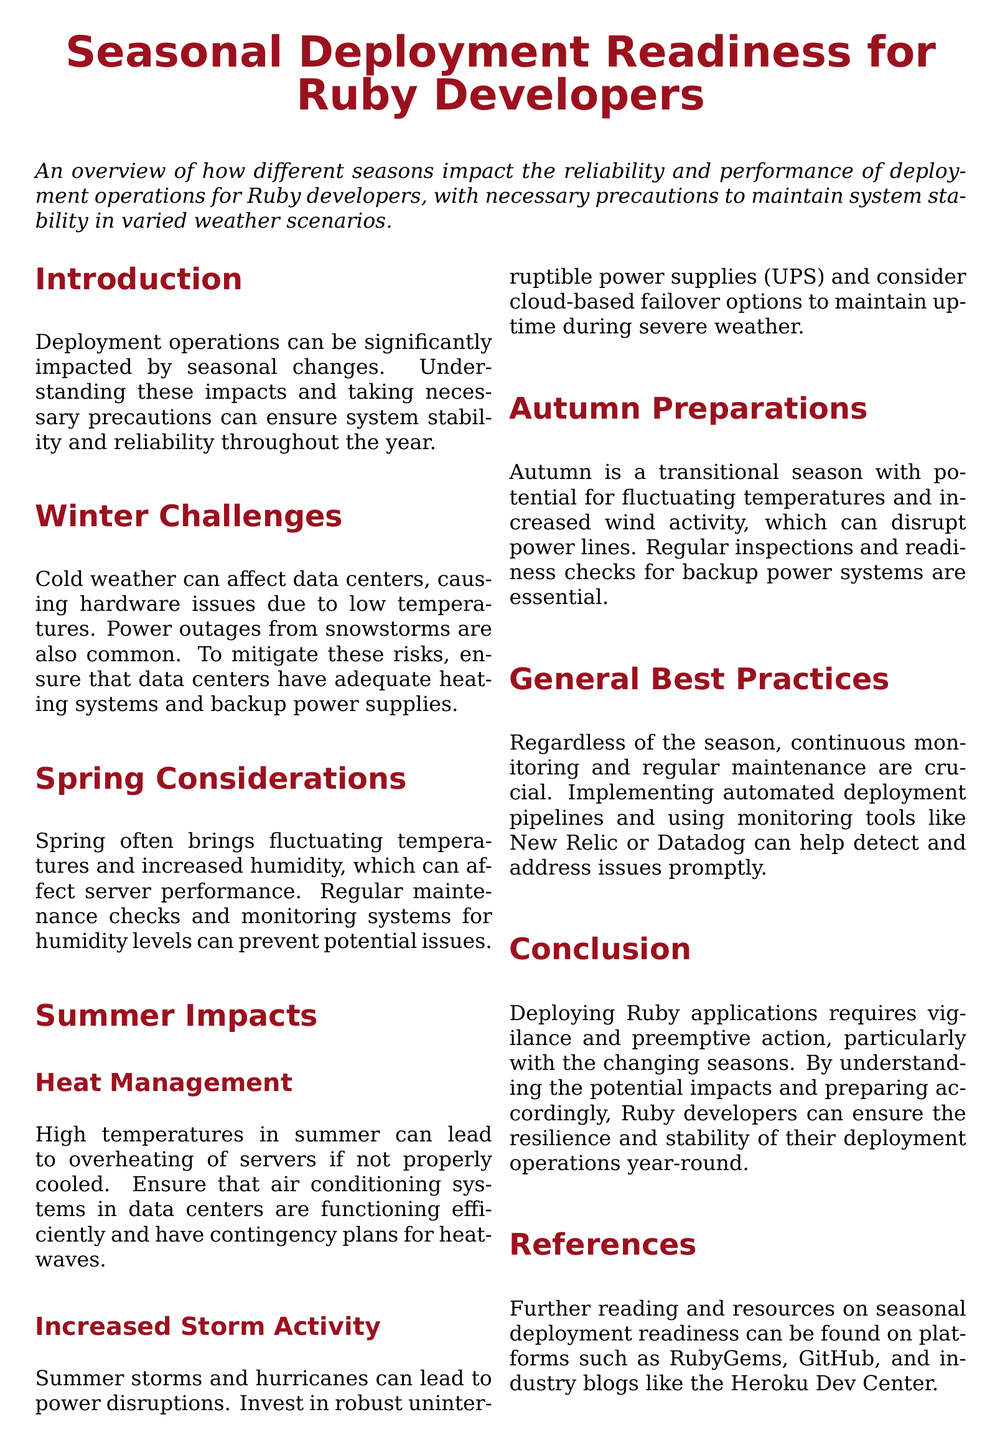what is the title of the document? The title of the document is prominently displayed at the top section, indicating its focus on seasonal deployment readiness for Ruby developers.
Answer: Seasonal Deployment Readiness for Ruby Developers what season can cause hardware issues due to low temperatures? This information is found in the section discussing winter challenges and the impact of cold weather.
Answer: Winter what should be checked regularly during spring? The spring considerations section advises on what specific maintenance checks should be performed to prevent issues.
Answer: Humidity levels what is a key strategy to prevent overheating in summer? The summer impacts section specifically mentions a solution to manage heat effectively.
Answer: Cooling systems which season requires inspections for backup power systems? This is mentioned in the autumn preparations section, highlighting the need for proactive measures.
Answer: Autumn what monitoring tools are mentioned in the general best practices? The general best practices section lists specific tools that can help in monitoring deployment operations.
Answer: New Relic and Datadog what type of power supplies should be invested in for summer storms? The summer impacts section highlights a specific type of technology as a precaution for handling severe weather.
Answer: Uninterruptible power supplies (UPS) how often should continuous monitoring be performed? This is a general principle mentioned in the best practices section regarding maintenance and system reliability.
Answer: Continuously 